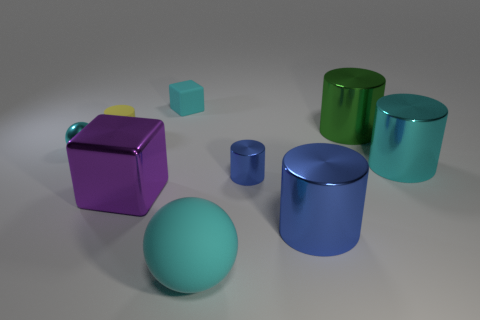What number of things are either big green metallic spheres or things that are on the left side of the yellow matte thing? In the image, there is one large green metallic sphere and three objects that are on the left side of the small yellow matte cube - a large purple cube, a large cyan cylinder, and a small teal cube. Therefore, there are four items that fit the criteria. 